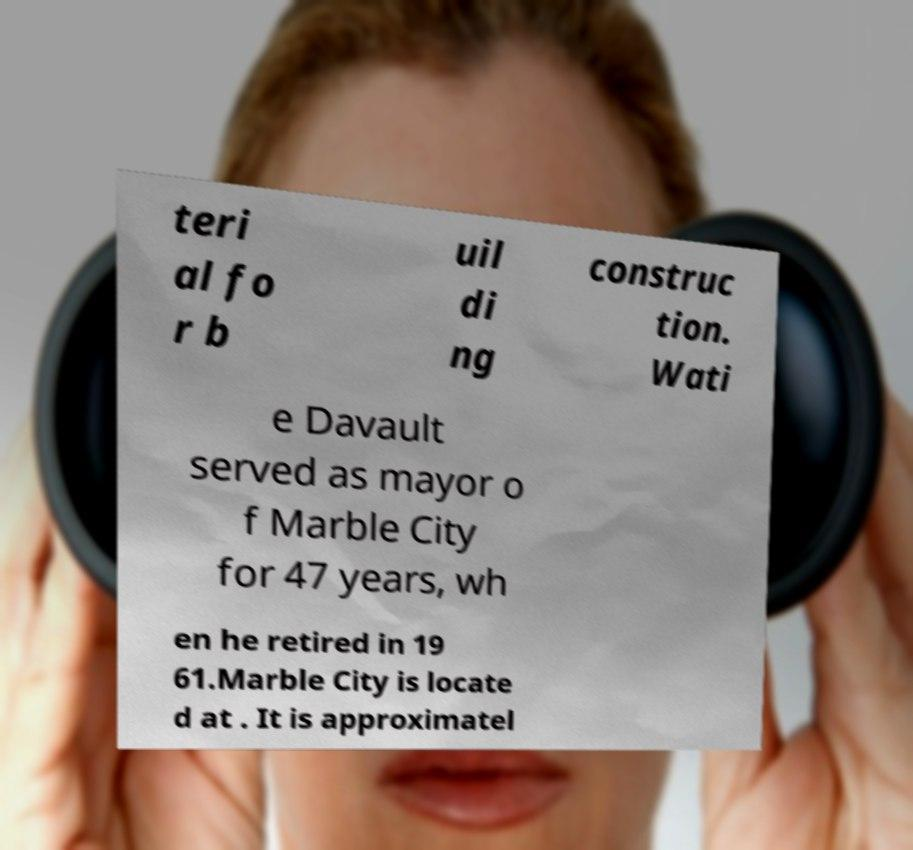What messages or text are displayed in this image? I need them in a readable, typed format. teri al fo r b uil di ng construc tion. Wati e Davault served as mayor o f Marble City for 47 years, wh en he retired in 19 61.Marble City is locate d at . It is approximatel 